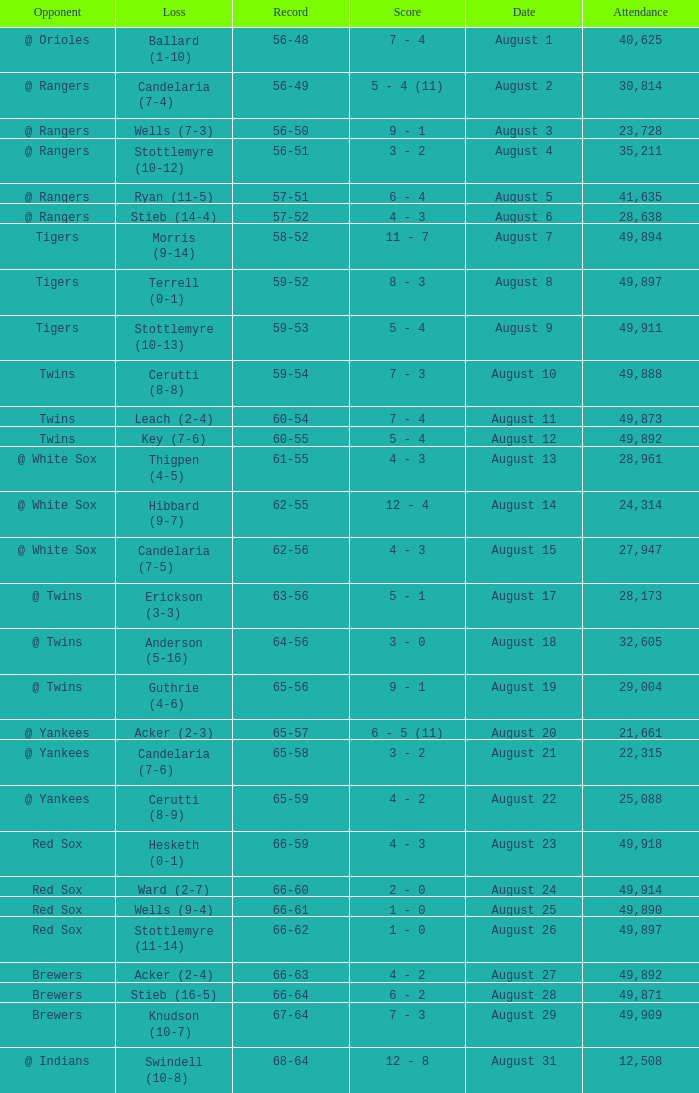What was the Attendance high on August 28? 49871.0. 